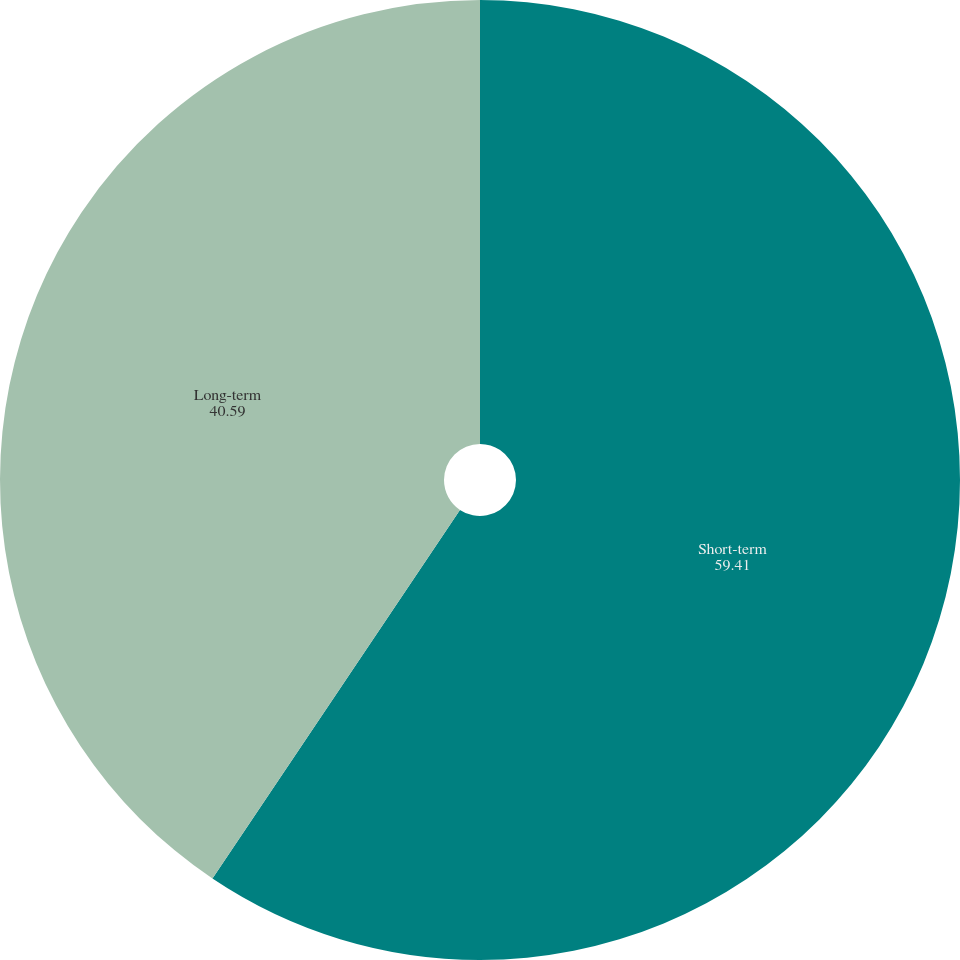Convert chart to OTSL. <chart><loc_0><loc_0><loc_500><loc_500><pie_chart><fcel>Short-term<fcel>Long-term<nl><fcel>59.41%<fcel>40.59%<nl></chart> 